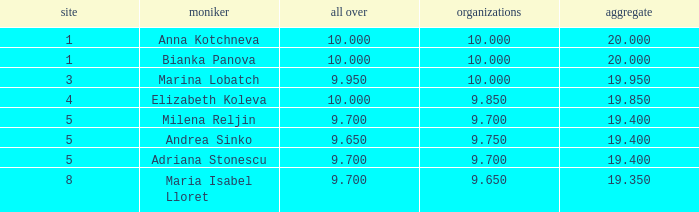What are the lowest clubs that have a place greater than 5, with an all around greater than 9.7? None. 